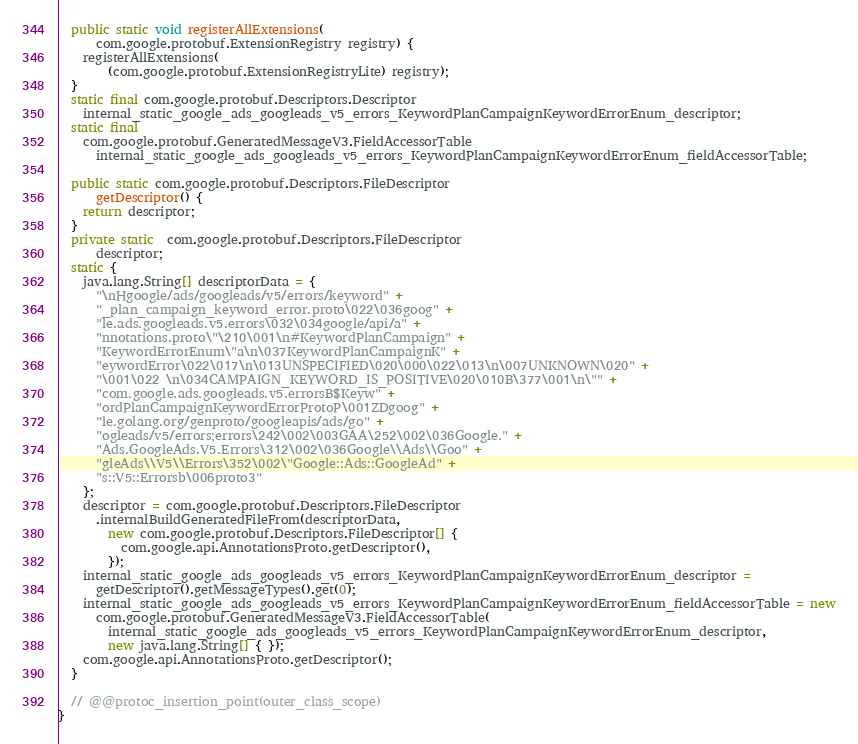<code> <loc_0><loc_0><loc_500><loc_500><_Java_>  public static void registerAllExtensions(
      com.google.protobuf.ExtensionRegistry registry) {
    registerAllExtensions(
        (com.google.protobuf.ExtensionRegistryLite) registry);
  }
  static final com.google.protobuf.Descriptors.Descriptor
    internal_static_google_ads_googleads_v5_errors_KeywordPlanCampaignKeywordErrorEnum_descriptor;
  static final 
    com.google.protobuf.GeneratedMessageV3.FieldAccessorTable
      internal_static_google_ads_googleads_v5_errors_KeywordPlanCampaignKeywordErrorEnum_fieldAccessorTable;

  public static com.google.protobuf.Descriptors.FileDescriptor
      getDescriptor() {
    return descriptor;
  }
  private static  com.google.protobuf.Descriptors.FileDescriptor
      descriptor;
  static {
    java.lang.String[] descriptorData = {
      "\nHgoogle/ads/googleads/v5/errors/keyword" +
      "_plan_campaign_keyword_error.proto\022\036goog" +
      "le.ads.googleads.v5.errors\032\034google/api/a" +
      "nnotations.proto\"\210\001\n#KeywordPlanCampaign" +
      "KeywordErrorEnum\"a\n\037KeywordPlanCampaignK" +
      "eywordError\022\017\n\013UNSPECIFIED\020\000\022\013\n\007UNKNOWN\020" +
      "\001\022 \n\034CAMPAIGN_KEYWORD_IS_POSITIVE\020\010B\377\001\n\"" +
      "com.google.ads.googleads.v5.errorsB$Keyw" +
      "ordPlanCampaignKeywordErrorProtoP\001ZDgoog" +
      "le.golang.org/genproto/googleapis/ads/go" +
      "ogleads/v5/errors;errors\242\002\003GAA\252\002\036Google." +
      "Ads.GoogleAds.V5.Errors\312\002\036Google\\Ads\\Goo" +
      "gleAds\\V5\\Errors\352\002\"Google::Ads::GoogleAd" +
      "s::V5::Errorsb\006proto3"
    };
    descriptor = com.google.protobuf.Descriptors.FileDescriptor
      .internalBuildGeneratedFileFrom(descriptorData,
        new com.google.protobuf.Descriptors.FileDescriptor[] {
          com.google.api.AnnotationsProto.getDescriptor(),
        });
    internal_static_google_ads_googleads_v5_errors_KeywordPlanCampaignKeywordErrorEnum_descriptor =
      getDescriptor().getMessageTypes().get(0);
    internal_static_google_ads_googleads_v5_errors_KeywordPlanCampaignKeywordErrorEnum_fieldAccessorTable = new
      com.google.protobuf.GeneratedMessageV3.FieldAccessorTable(
        internal_static_google_ads_googleads_v5_errors_KeywordPlanCampaignKeywordErrorEnum_descriptor,
        new java.lang.String[] { });
    com.google.api.AnnotationsProto.getDescriptor();
  }

  // @@protoc_insertion_point(outer_class_scope)
}
</code> 